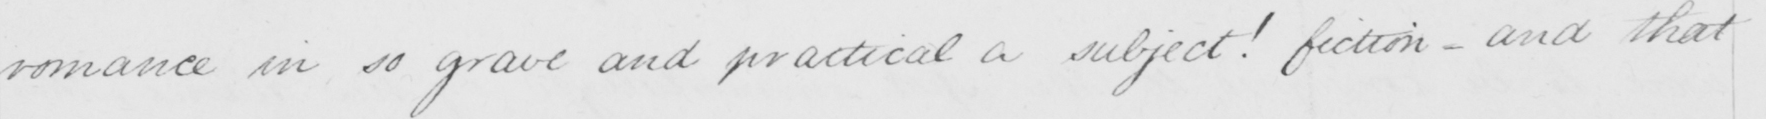What is written in this line of handwriting? romance in so grave and practical a subject !  fiction  _  and that 